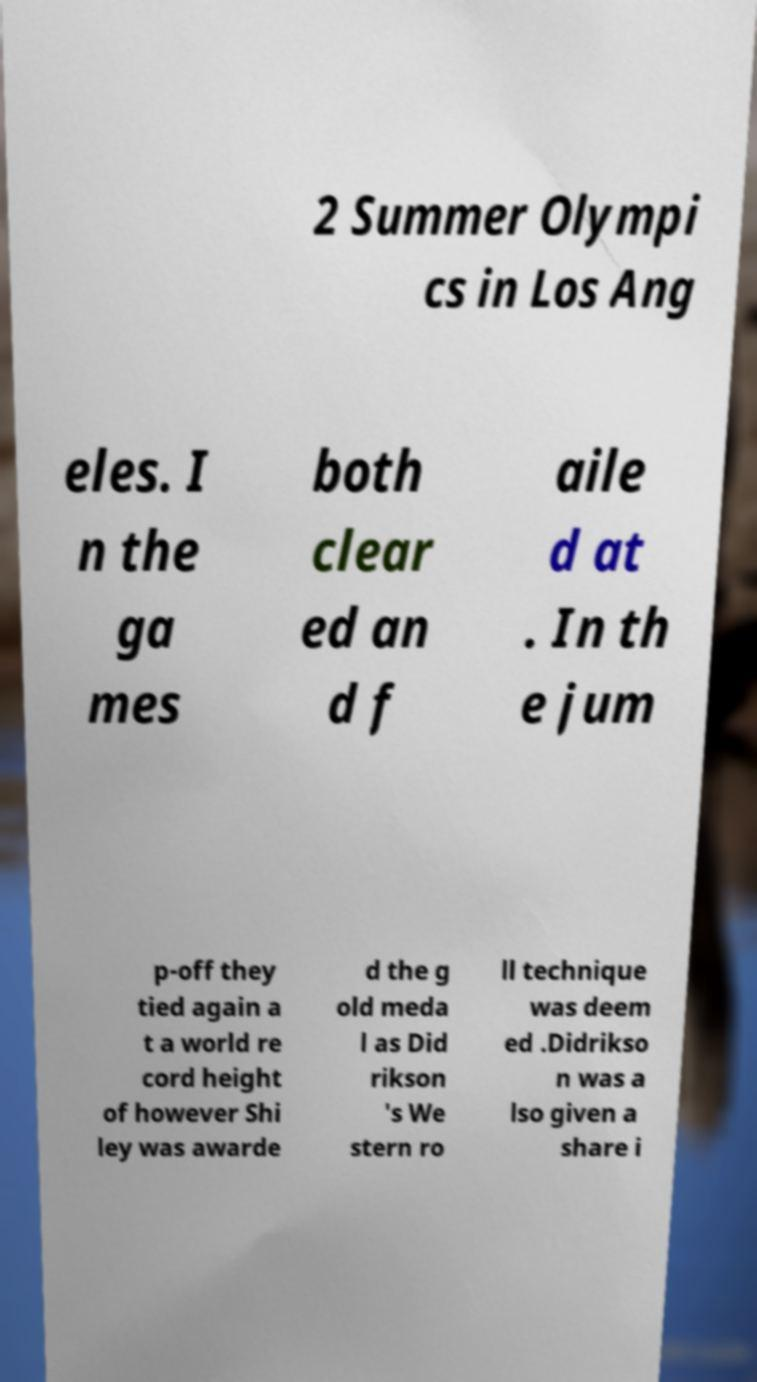There's text embedded in this image that I need extracted. Can you transcribe it verbatim? 2 Summer Olympi cs in Los Ang eles. I n the ga mes both clear ed an d f aile d at . In th e jum p-off they tied again a t a world re cord height of however Shi ley was awarde d the g old meda l as Did rikson 's We stern ro ll technique was deem ed .Didrikso n was a lso given a share i 